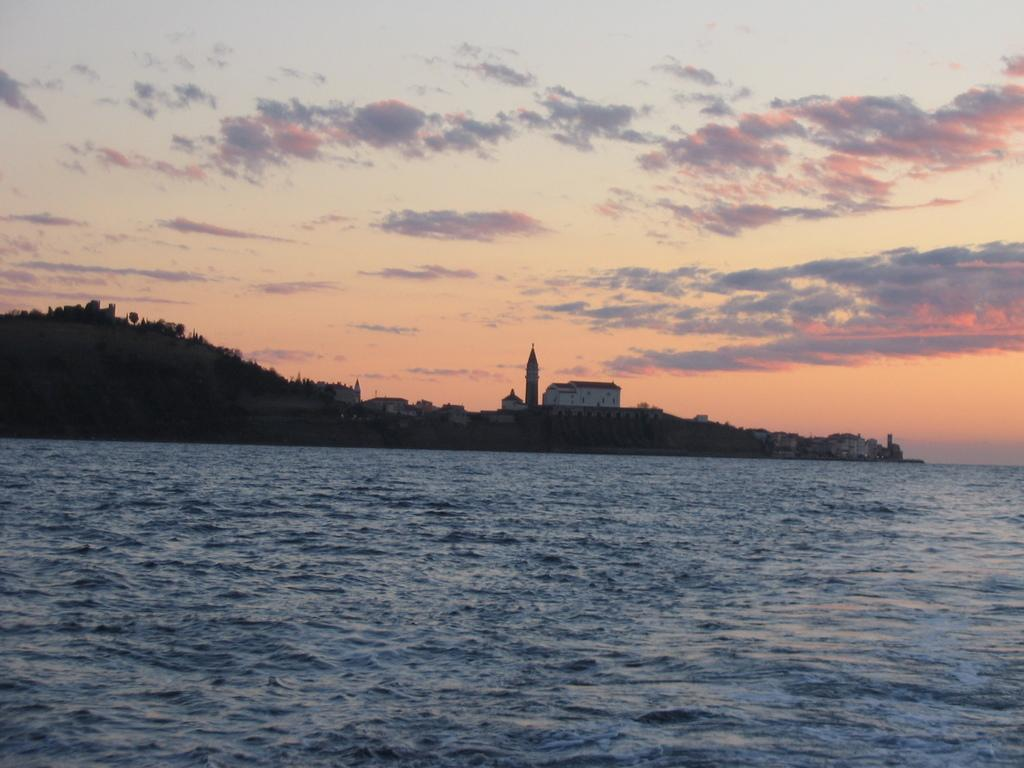Where was the image taken? The image was clicked outside the city. What is in the foreground of the image? There is a water body in the foreground of the image. What can be seen in the background of the image? There are buildings, trees, and the sky visible in the background of the image. What is the condition of the sky in the image? Clouds are present in the sky in the image. Can you see a person kicking a ball in the image? No, there is no person kicking a ball in the image. 